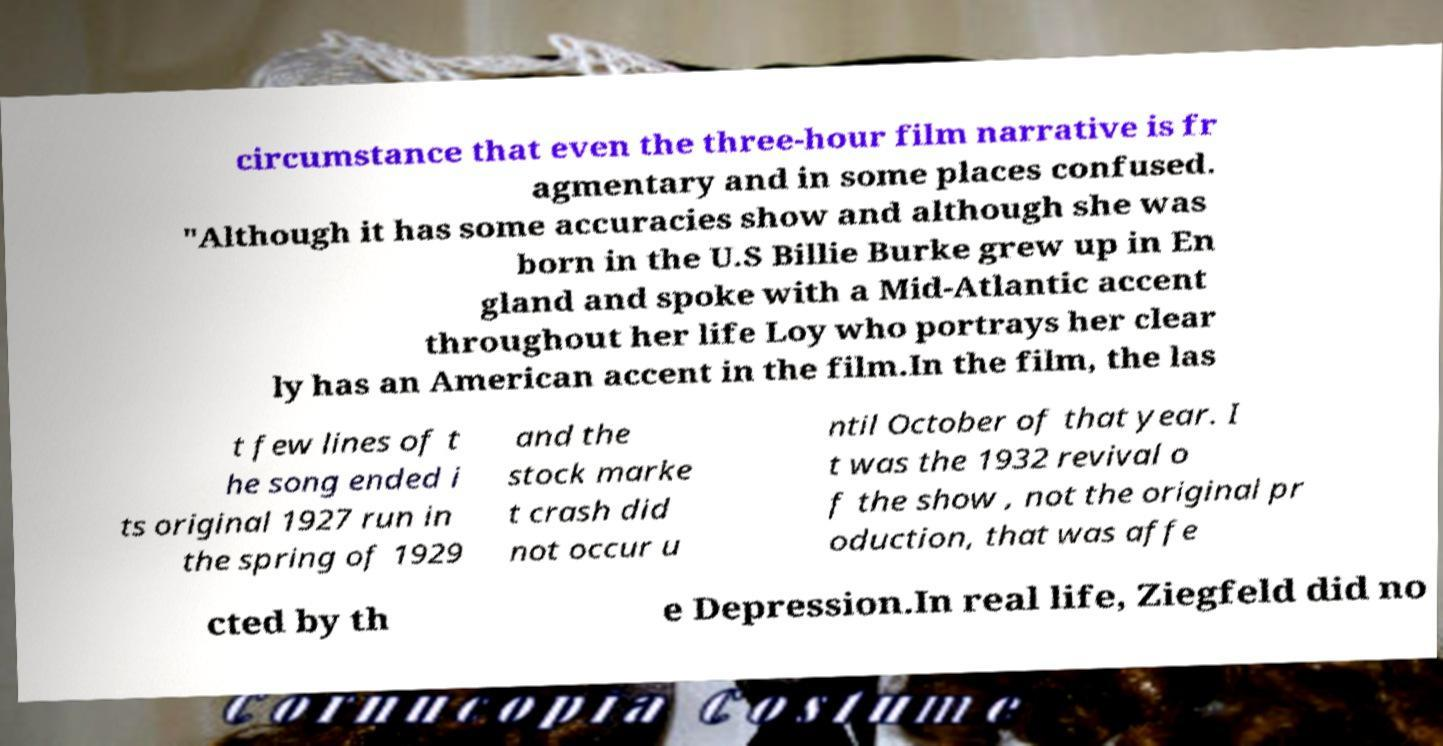Can you accurately transcribe the text from the provided image for me? circumstance that even the three-hour film narrative is fr agmentary and in some places confused. "Although it has some accuracies show and although she was born in the U.S Billie Burke grew up in En gland and spoke with a Mid-Atlantic accent throughout her life Loy who portrays her clear ly has an American accent in the film.In the film, the las t few lines of t he song ended i ts original 1927 run in the spring of 1929 and the stock marke t crash did not occur u ntil October of that year. I t was the 1932 revival o f the show , not the original pr oduction, that was affe cted by th e Depression.In real life, Ziegfeld did no 